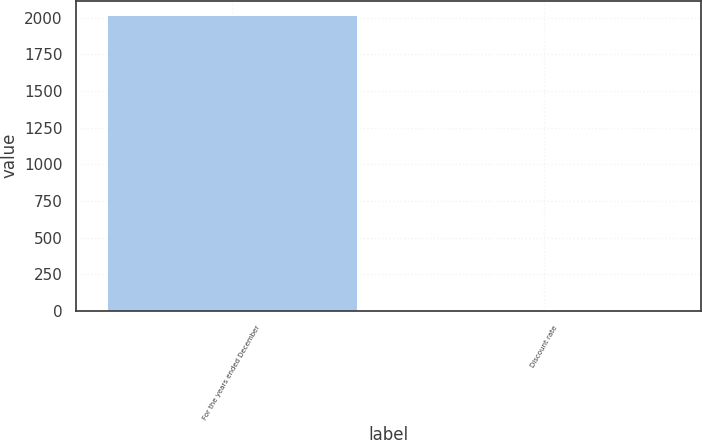<chart> <loc_0><loc_0><loc_500><loc_500><bar_chart><fcel>For the years ended December<fcel>Discount rate<nl><fcel>2015<fcel>3.7<nl></chart> 